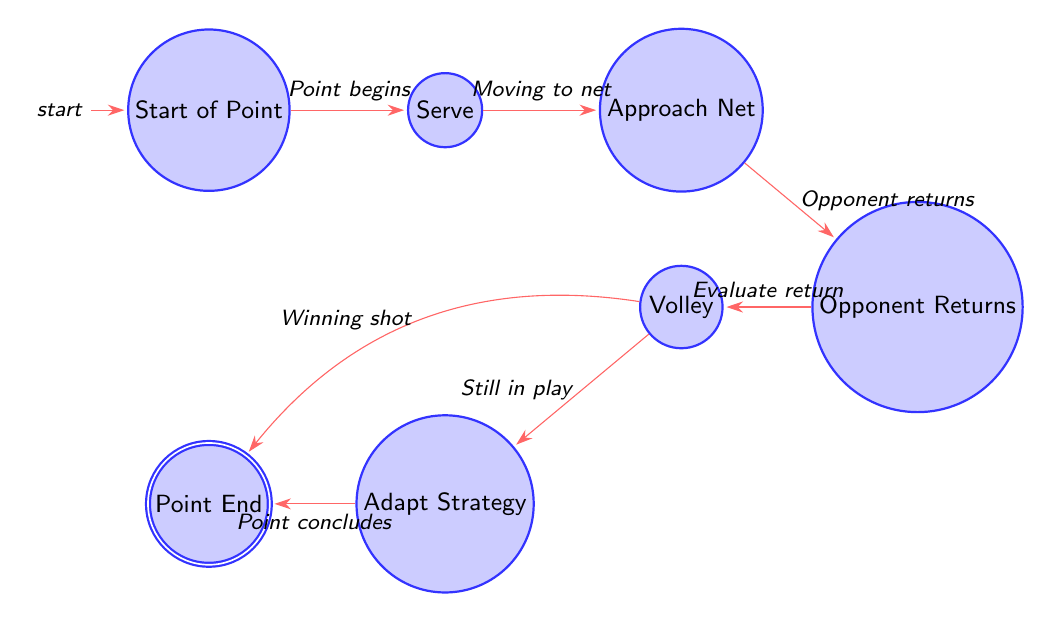What is the first state in the diagram? The diagram begins with the state named "Start_of_Point," which represents the beginning of a point in tennis.
Answer: Start_of_Point How many states are there in total? The diagram contains a total of 6 states: Start_of_Point, Serve, Approach_Net, Opponent_Returns, Volley, and Adapt_Strategy.
Answer: 6 What happens after the Serve state? After the Serve state, the next state is "Approach_Net," indicating the player moves towards the net after executing the serve.
Answer: Approach_Net What is the condition to move from Opponent_Returns to Volley? The transition from Opponent_Returns to Volley occurs when the player is "Evaluating opponent's return."
Answer: Evaluating opponent's return If the Volley is executed, what state can the player transition to? After executing the Volley, the player can transition to either Adapt_Strategy or Point_End depending on the outcome of the volley. The specific condition for Adapt_Strategy is "Still in play."
Answer: Adapt_Strategy or Point_End What is the last state before concluding a point? The last state before concluding a point is "Adapt_Strategy," where the player adjusts their strategy based on the point's outcome.
Answer: Adapt_Strategy Is it possible to go directly from Volley to Point_End? Yes, it is possible to go directly from Volley to Point_End if it is a winning shot or the point ends.
Answer: Yes What do we learn about the game's strategy from this diagram? The diagram suggests that after each shot, players continuously assess their opponent's responses to adapt their strategies throughout the game.
Answer: Assessing and adapting strategies 